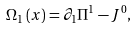<formula> <loc_0><loc_0><loc_500><loc_500>\Omega _ { 1 } \left ( x \right ) = \partial _ { 1 } \Pi ^ { 1 } - J ^ { 0 } ,</formula> 